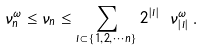<formula> <loc_0><loc_0><loc_500><loc_500>\nu _ { n } ^ { \omega } \leq \nu _ { n } \leq \sum _ { I \subset \{ 1 , 2 , \cdots n \} } 2 ^ { | I | } \ \nu _ { | I | } ^ { \omega } \, .</formula> 